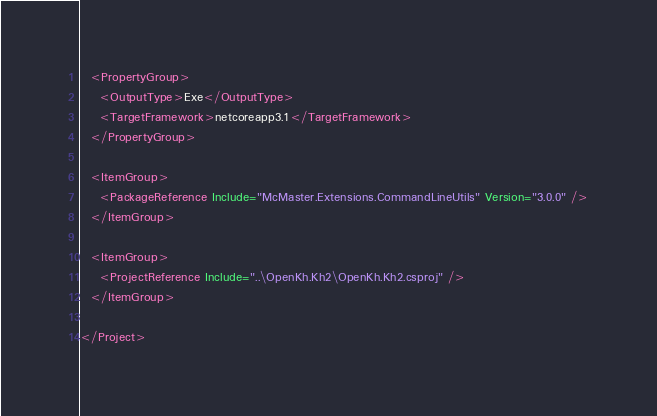<code> <loc_0><loc_0><loc_500><loc_500><_XML_>
  <PropertyGroup>
    <OutputType>Exe</OutputType>
    <TargetFramework>netcoreapp3.1</TargetFramework>
  </PropertyGroup>

  <ItemGroup>
    <PackageReference Include="McMaster.Extensions.CommandLineUtils" Version="3.0.0" />
  </ItemGroup>

  <ItemGroup>
    <ProjectReference Include="..\OpenKh.Kh2\OpenKh.Kh2.csproj" />
  </ItemGroup>

</Project>
</code> 